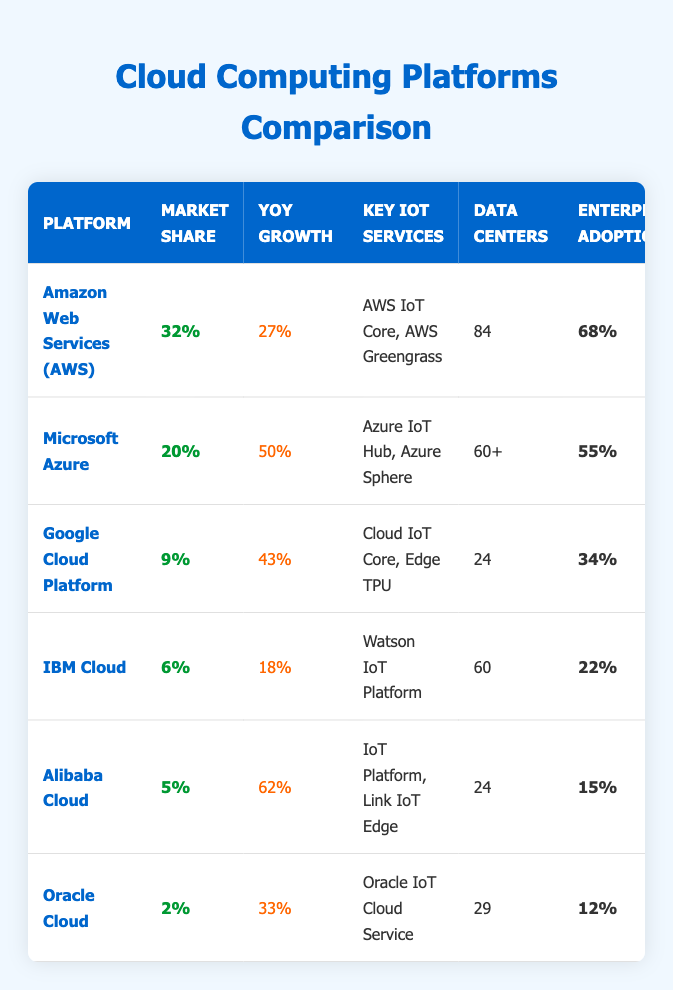What is the market share of Microsoft Azure? According to the table, Microsoft Azure has a market share listed as 20%.
Answer: 20% Which cloud platform has the highest number of data centers? The table shows that Amazon Web Services (AWS) has 84 data centers, which is the highest among the listed platforms.
Answer: Amazon Web Services (AWS) What is the year-over-year growth of Alibaba Cloud? From the table, Alibaba Cloud shows a year-over-year growth of 62%.
Answer: 62% Is there a free tier available for IBM Cloud? The table indicates that there is a free tier available for IBM Cloud since it is marked as "Yes."
Answer: Yes What is the average market share of the platforms listed? To find the average, we add up the market shares: 32% + 20% + 9% + 6% + 5% + 2% = 74%, then divide by 6 (the number of platforms), giving us an average market share of approximately 12.33%.
Answer: 12.33% Which platform shows the lowest enterprise adoption rate and what is that rate? Looking at the table, Oracle Cloud shows the lowest enterprise adoption rate at 12%.
Answer: 12% How does the year-over-year growth of Google Cloud compare to IBM Cloud? Google Cloud Platform has a year-over-year growth of 43%, while IBM Cloud has a growth of 18%. The difference is 43% - 18% = 25%. Google Cloud's growth is 25% higher than IBM's.
Answer: Google Cloud is 25% higher How many platforms have a startup-friendly pricing rating of 4 or above? From the table, AWS, Microsoft Azure, and Alibaba Cloud all have a startup-friendly pricing rating of 4 or above (4/5 and 4.5/5), totaling 3 platforms.
Answer: 3 platforms Which cloud platform has the least number of data centers? The table shows that Google Cloud Platform and Alibaba Cloud both have 24 data centers, making them tied for the least number of data centers among the listed platforms.
Answer: Google Cloud Platform and Alibaba Cloud 